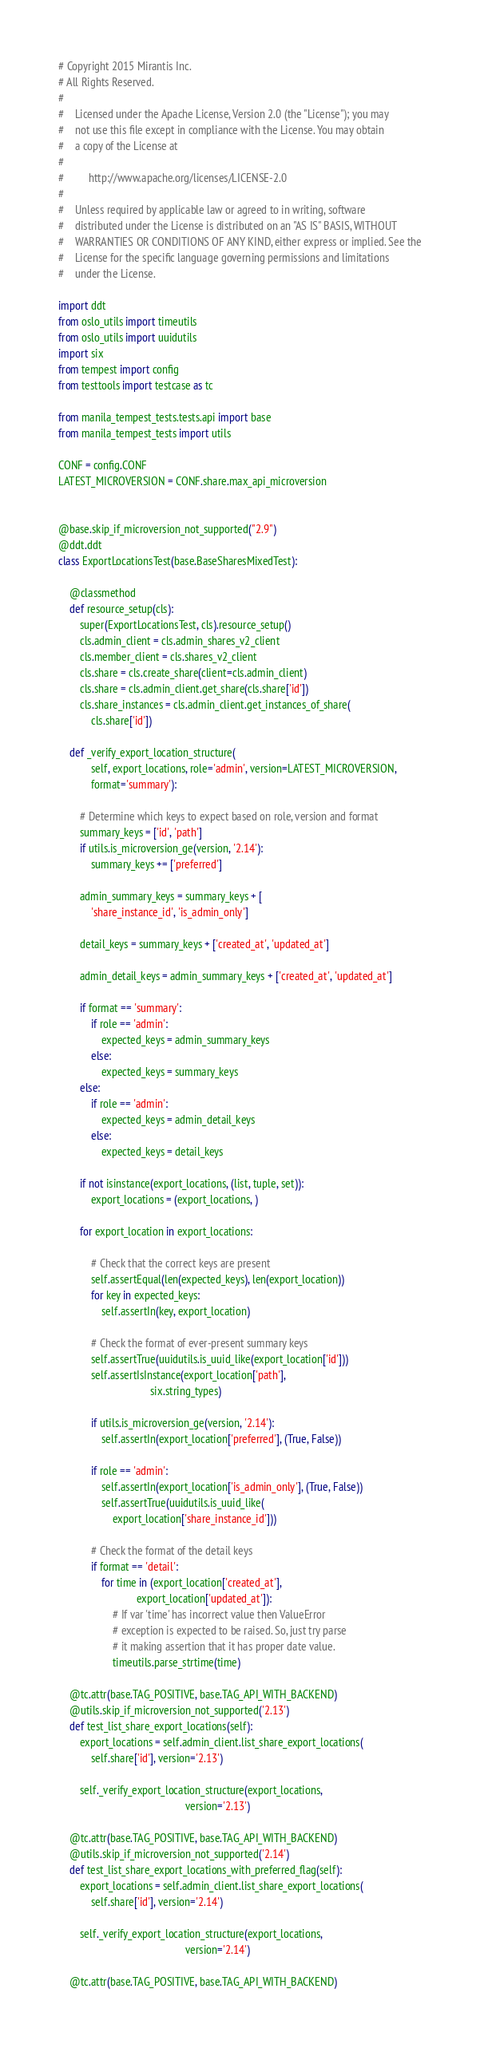<code> <loc_0><loc_0><loc_500><loc_500><_Python_># Copyright 2015 Mirantis Inc.
# All Rights Reserved.
#
#    Licensed under the Apache License, Version 2.0 (the "License"); you may
#    not use this file except in compliance with the License. You may obtain
#    a copy of the License at
#
#         http://www.apache.org/licenses/LICENSE-2.0
#
#    Unless required by applicable law or agreed to in writing, software
#    distributed under the License is distributed on an "AS IS" BASIS, WITHOUT
#    WARRANTIES OR CONDITIONS OF ANY KIND, either express or implied. See the
#    License for the specific language governing permissions and limitations
#    under the License.

import ddt
from oslo_utils import timeutils
from oslo_utils import uuidutils
import six
from tempest import config
from testtools import testcase as tc

from manila_tempest_tests.tests.api import base
from manila_tempest_tests import utils

CONF = config.CONF
LATEST_MICROVERSION = CONF.share.max_api_microversion


@base.skip_if_microversion_not_supported("2.9")
@ddt.ddt
class ExportLocationsTest(base.BaseSharesMixedTest):

    @classmethod
    def resource_setup(cls):
        super(ExportLocationsTest, cls).resource_setup()
        cls.admin_client = cls.admin_shares_v2_client
        cls.member_client = cls.shares_v2_client
        cls.share = cls.create_share(client=cls.admin_client)
        cls.share = cls.admin_client.get_share(cls.share['id'])
        cls.share_instances = cls.admin_client.get_instances_of_share(
            cls.share['id'])

    def _verify_export_location_structure(
            self, export_locations, role='admin', version=LATEST_MICROVERSION,
            format='summary'):

        # Determine which keys to expect based on role, version and format
        summary_keys = ['id', 'path']
        if utils.is_microversion_ge(version, '2.14'):
            summary_keys += ['preferred']

        admin_summary_keys = summary_keys + [
            'share_instance_id', 'is_admin_only']

        detail_keys = summary_keys + ['created_at', 'updated_at']

        admin_detail_keys = admin_summary_keys + ['created_at', 'updated_at']

        if format == 'summary':
            if role == 'admin':
                expected_keys = admin_summary_keys
            else:
                expected_keys = summary_keys
        else:
            if role == 'admin':
                expected_keys = admin_detail_keys
            else:
                expected_keys = detail_keys

        if not isinstance(export_locations, (list, tuple, set)):
            export_locations = (export_locations, )

        for export_location in export_locations:

            # Check that the correct keys are present
            self.assertEqual(len(expected_keys), len(export_location))
            for key in expected_keys:
                self.assertIn(key, export_location)

            # Check the format of ever-present summary keys
            self.assertTrue(uuidutils.is_uuid_like(export_location['id']))
            self.assertIsInstance(export_location['path'],
                                  six.string_types)

            if utils.is_microversion_ge(version, '2.14'):
                self.assertIn(export_location['preferred'], (True, False))

            if role == 'admin':
                self.assertIn(export_location['is_admin_only'], (True, False))
                self.assertTrue(uuidutils.is_uuid_like(
                    export_location['share_instance_id']))

            # Check the format of the detail keys
            if format == 'detail':
                for time in (export_location['created_at'],
                             export_location['updated_at']):
                    # If var 'time' has incorrect value then ValueError
                    # exception is expected to be raised. So, just try parse
                    # it making assertion that it has proper date value.
                    timeutils.parse_strtime(time)

    @tc.attr(base.TAG_POSITIVE, base.TAG_API_WITH_BACKEND)
    @utils.skip_if_microversion_not_supported('2.13')
    def test_list_share_export_locations(self):
        export_locations = self.admin_client.list_share_export_locations(
            self.share['id'], version='2.13')

        self._verify_export_location_structure(export_locations,
                                               version='2.13')

    @tc.attr(base.TAG_POSITIVE, base.TAG_API_WITH_BACKEND)
    @utils.skip_if_microversion_not_supported('2.14')
    def test_list_share_export_locations_with_preferred_flag(self):
        export_locations = self.admin_client.list_share_export_locations(
            self.share['id'], version='2.14')

        self._verify_export_location_structure(export_locations,
                                               version='2.14')

    @tc.attr(base.TAG_POSITIVE, base.TAG_API_WITH_BACKEND)</code> 